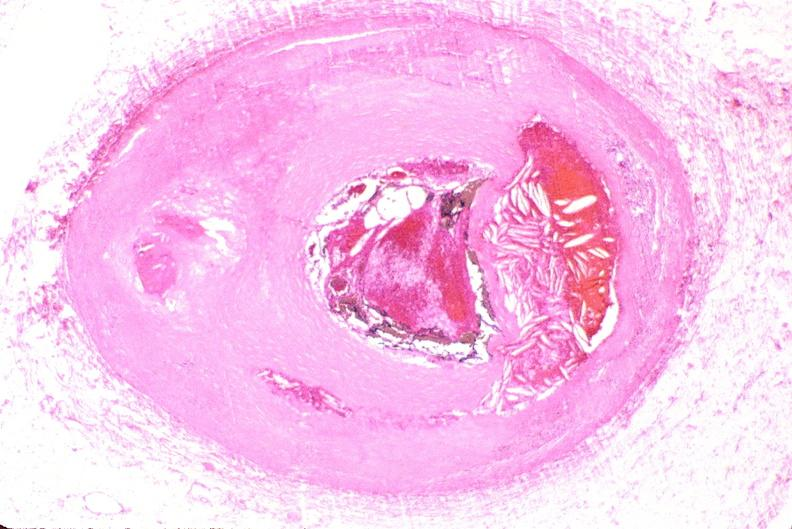s leiomyosarcoma present?
Answer the question using a single word or phrase. No 